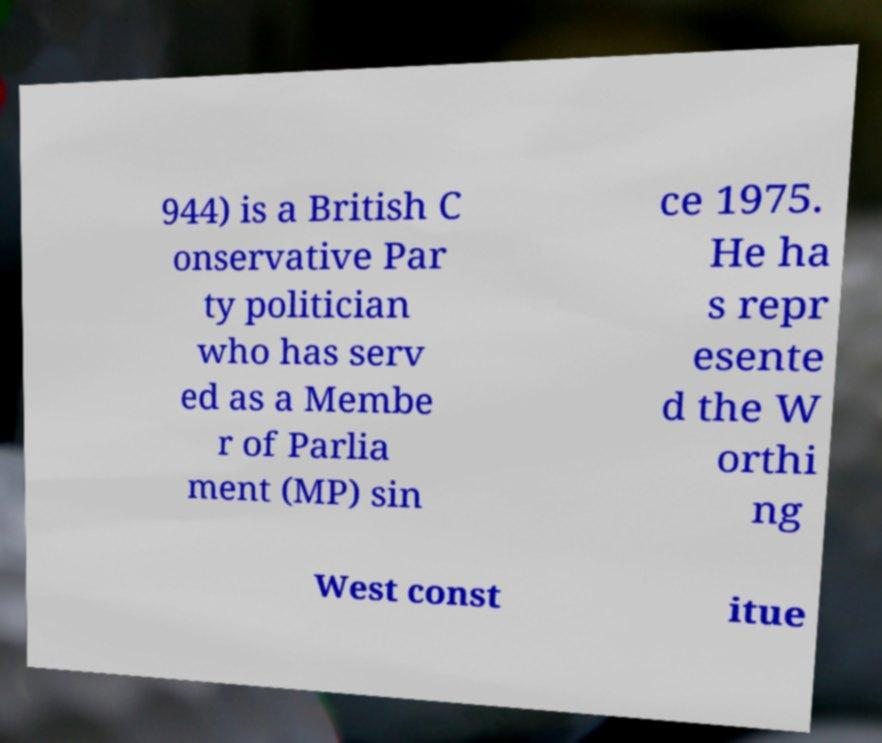What messages or text are displayed in this image? I need them in a readable, typed format. 944) is a British C onservative Par ty politician who has serv ed as a Membe r of Parlia ment (MP) sin ce 1975. He ha s repr esente d the W orthi ng West const itue 